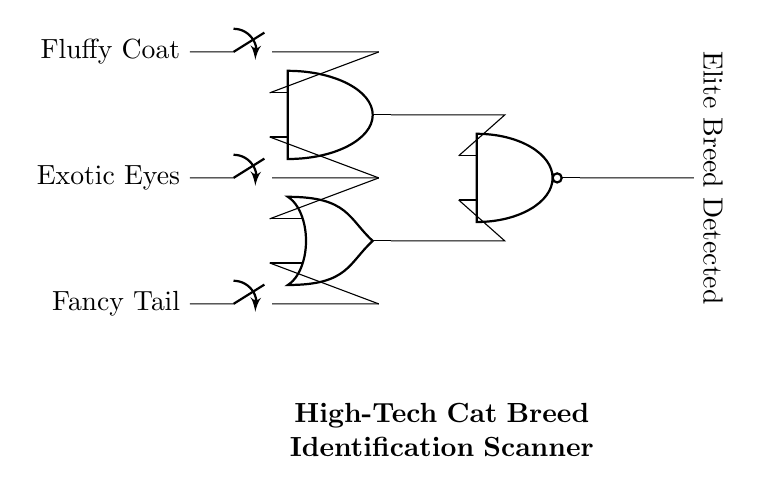What components are present in this circuit? The components include switches, an AND gate, an OR gate, and a NAND gate. Each of these plays a critical role in the logical operation of the circuit. The switches represent the inputs related to cat breed characteristics, and the gates perform logical operations to determine the output.
Answer: switches, AND gate, OR gate, NAND gate What is the output of the circuit when all inputs are active? When all inputs (Fluffy Coat, Exotic Eyes, Fancy Tail) are active, the AND gate outputs a high signal because both inputs are true, and combining that with the OR gate's output leads to a low signal at the NAND gate input. Thus, the NAND gate will output low, indicating no elite breed detected.
Answer: low How many input switches are used in the circuit? There are three input switches in the circuit, one for each of the characteristics: Fluffy Coat, Exotic Eyes, and Fancy Tail. Each switch controls whether the corresponding characteristic is present, influencing the output of the gates.
Answer: three What logical operation does the NAND gate perform in this circuit? The NAND gate performs a negated AND operation. It takes the outputs from the AND gate and OR gate, and if both inputs are high, it outputs low, otherwise it outputs high. This operation helps determine if the elite breed is detected based on the combined inputs.
Answer: negated AND If the Fancy Tail switch is off, what will be the state of the output? If the Fancy Tail switch is off, it will not contribute to the OR gate. However, the AND gate will still check the other two inputs. If Fluffy Coat and Exotic Eyes are active, AND outputs high, making NAND output low. With only one switch off, we cannot confidently assume an elite breed is detected, so further checks are required.
Answer: low 